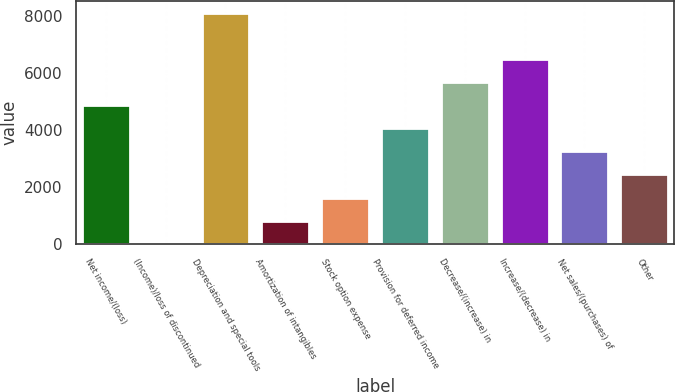Convert chart. <chart><loc_0><loc_0><loc_500><loc_500><bar_chart><fcel>Net income/(loss)<fcel>(Income)/loss of discontinued<fcel>Depreciation and special tools<fcel>Amortization of intangibles<fcel>Stock option expense<fcel>Provision for deferred income<fcel>Decrease/(increase) in<fcel>Increase/(decrease) in<fcel>Net sales/(purchases) of<fcel>Other<nl><fcel>4882.2<fcel>6<fcel>8133<fcel>818.7<fcel>1631.4<fcel>4069.5<fcel>5694.9<fcel>6507.6<fcel>3256.8<fcel>2444.1<nl></chart> 